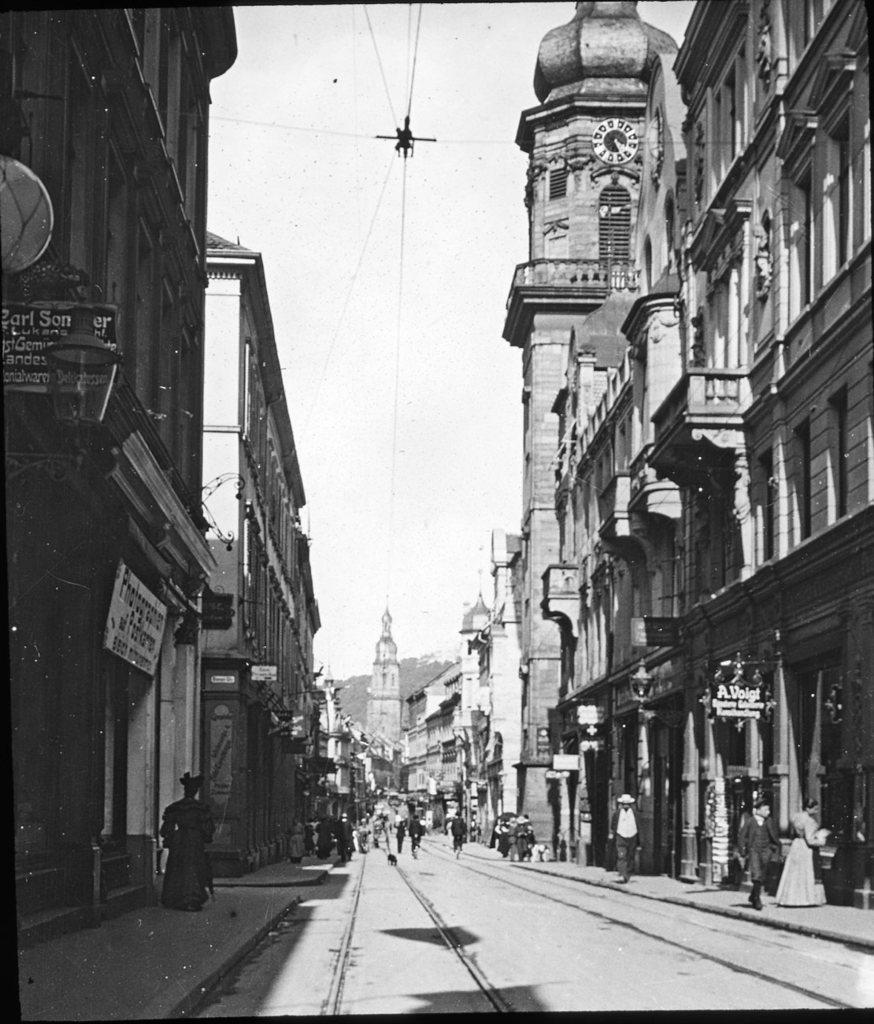Please provide a concise description of this image. There are buildings on the right and left side of the image, there are posters and stalls in the image, there are people at the bottom side of the image, there are wires at the top side and there is clock tower on the right side of the image. 